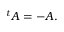Convert formula to latex. <formula><loc_0><loc_0><loc_500><loc_500>{ } ^ { t } A = - A .</formula> 